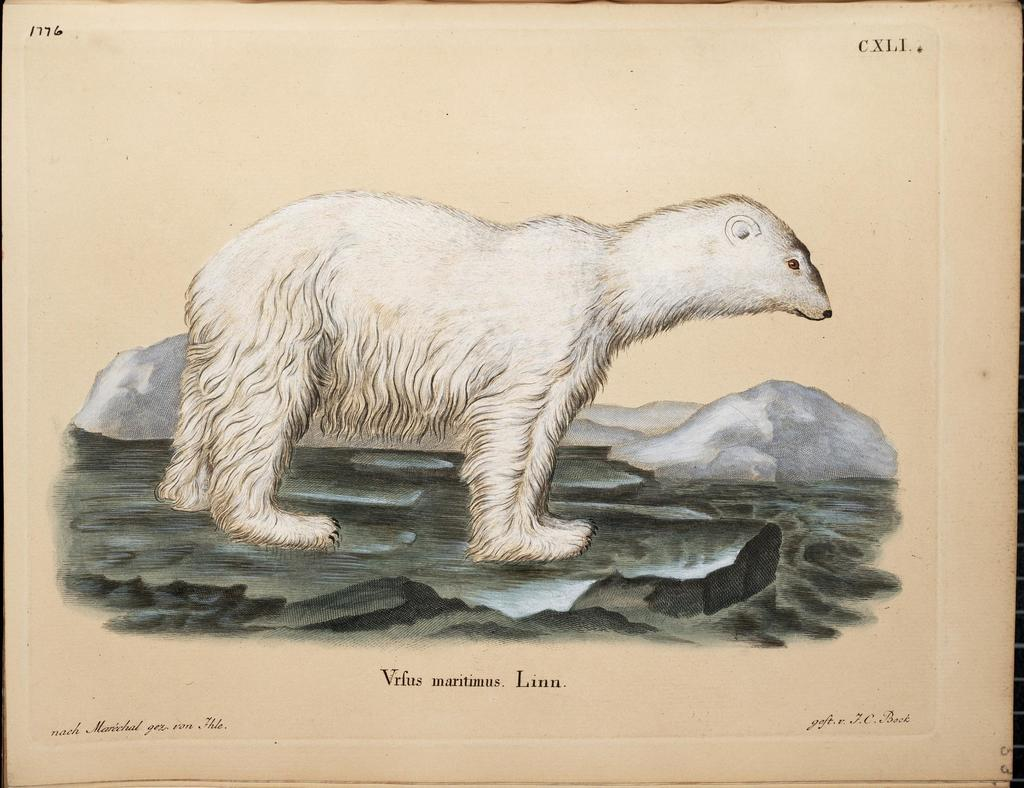What animal is the main subject of the image? There is a polar bear in the image. What is the color of the polar bear? The polar bear is white in color. What can be seen in the background of the image? There are mountains in the background of the image. Is there any text present in the image? Yes, there is text visible on the image. How many eyes does the gate have in the image? There is no gate present in the image, so it is not possible to determine the number of eyes it might have. 